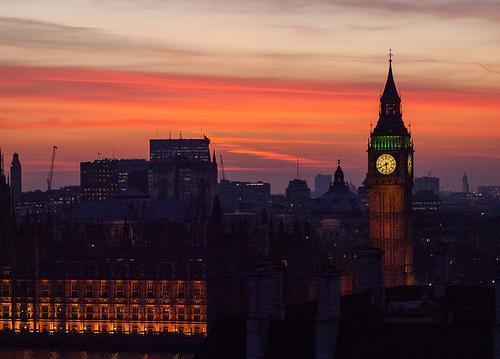How many clock faces are pictured?
Give a very brief answer. 2. How many clock towers are there?
Give a very brief answer. 1. 